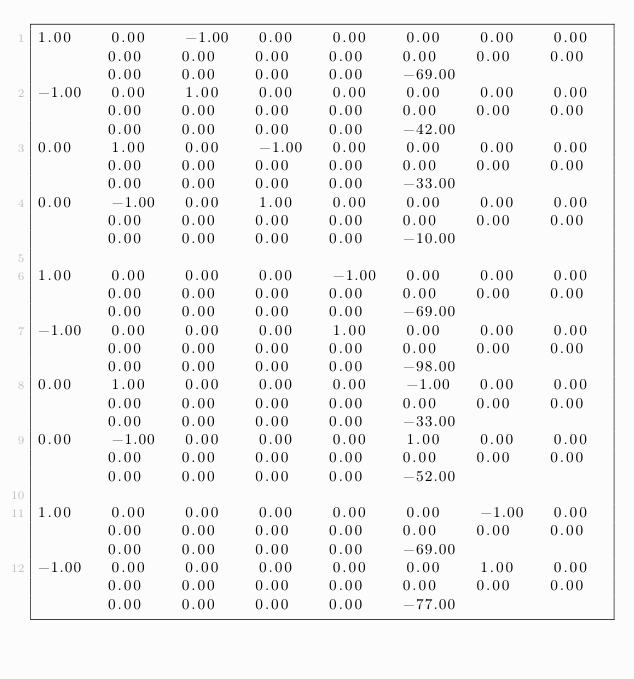Convert code to text. <code><loc_0><loc_0><loc_500><loc_500><_Matlab_>1.00	0.00	-1.00	0.00	0.00	0.00	0.00	0.00	0.00	0.00	0.00	0.00	0.00	0.00	0.00	0.00	0.00	0.00	0.00	-69.00
-1.00	0.00	1.00	0.00	0.00	0.00	0.00	0.00	0.00	0.00	0.00	0.00	0.00	0.00	0.00	0.00	0.00	0.00	0.00	-42.00
0.00	1.00	0.00	-1.00	0.00	0.00	0.00	0.00	0.00	0.00	0.00	0.00	0.00	0.00	0.00	0.00	0.00	0.00	0.00	-33.00
0.00	-1.00	0.00	1.00	0.00	0.00	0.00	0.00	0.00	0.00	0.00	0.00	0.00	0.00	0.00	0.00	0.00	0.00	0.00	-10.00

1.00	0.00	0.00	0.00	-1.00	0.00	0.00	0.00	0.00	0.00	0.00	0.00	0.00	0.00	0.00	0.00	0.00	0.00	0.00	-69.00
-1.00	0.00	0.00	0.00	1.00	0.00	0.00	0.00	0.00	0.00	0.00	0.00	0.00	0.00	0.00	0.00	0.00	0.00	0.00	-98.00
0.00	1.00	0.00	0.00	0.00	-1.00	0.00	0.00	0.00	0.00	0.00	0.00	0.00	0.00	0.00	0.00	0.00	0.00	0.00	-33.00
0.00	-1.00	0.00	0.00	0.00	1.00	0.00	0.00	0.00	0.00	0.00	0.00	0.00	0.00	0.00	0.00	0.00	0.00	0.00	-52.00

1.00	0.00	0.00	0.00	0.00	0.00	-1.00	0.00	0.00	0.00	0.00	0.00	0.00	0.00	0.00	0.00	0.00	0.00	0.00	-69.00
-1.00	0.00	0.00	0.00	0.00	0.00	1.00	0.00	0.00	0.00	0.00	0.00	0.00	0.00	0.00	0.00	0.00	0.00	0.00	-77.00</code> 